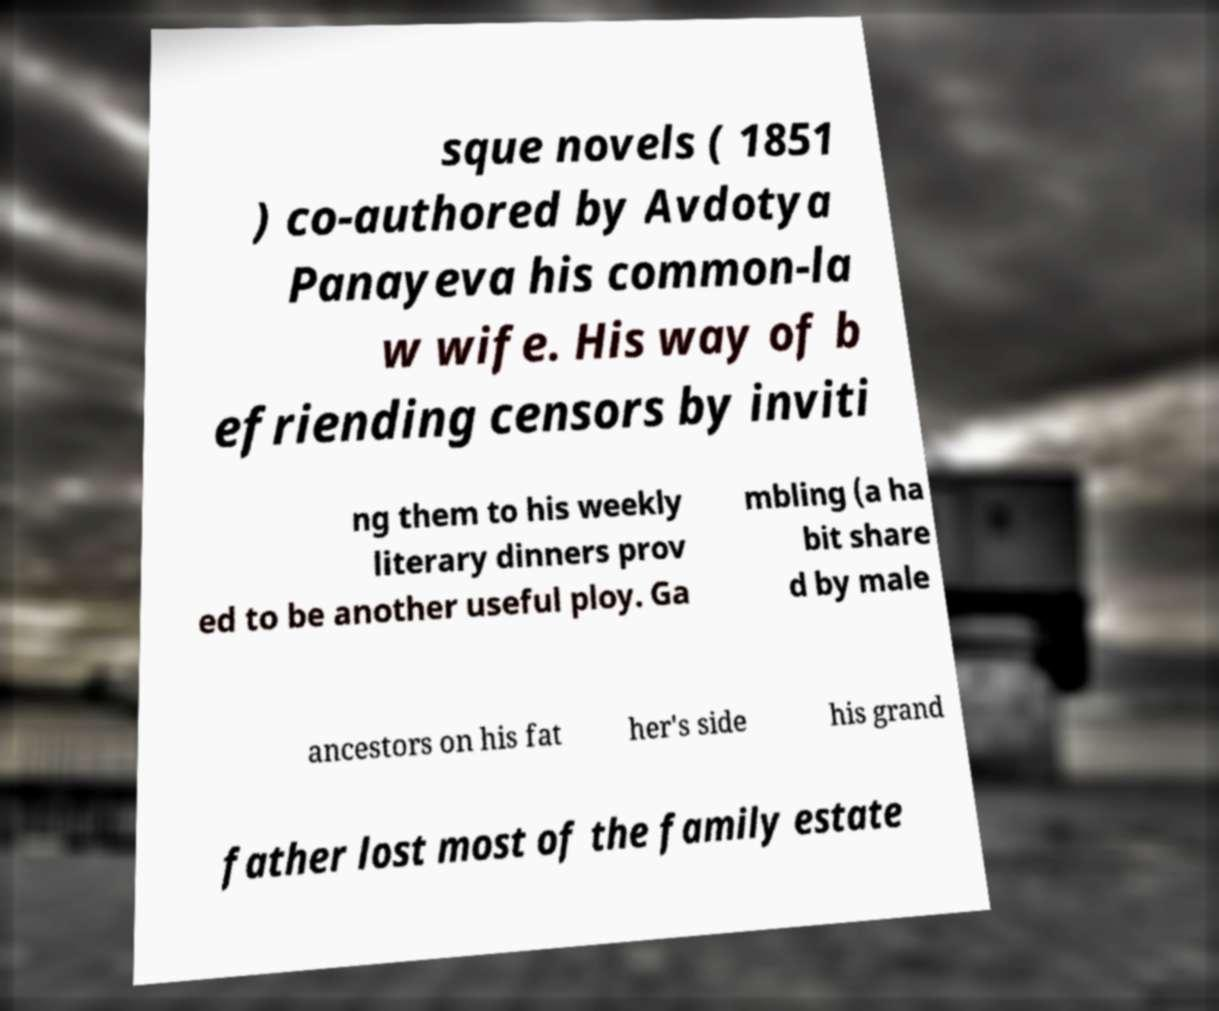I need the written content from this picture converted into text. Can you do that? sque novels ( 1851 ) co-authored by Avdotya Panayeva his common-la w wife. His way of b efriending censors by inviti ng them to his weekly literary dinners prov ed to be another useful ploy. Ga mbling (a ha bit share d by male ancestors on his fat her's side his grand father lost most of the family estate 